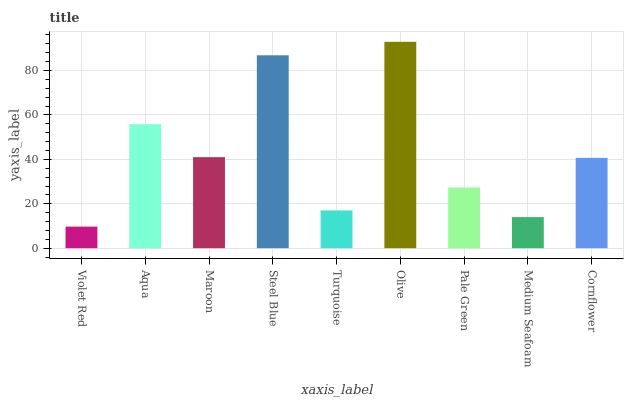Is Violet Red the minimum?
Answer yes or no. Yes. Is Olive the maximum?
Answer yes or no. Yes. Is Aqua the minimum?
Answer yes or no. No. Is Aqua the maximum?
Answer yes or no. No. Is Aqua greater than Violet Red?
Answer yes or no. Yes. Is Violet Red less than Aqua?
Answer yes or no. Yes. Is Violet Red greater than Aqua?
Answer yes or no. No. Is Aqua less than Violet Red?
Answer yes or no. No. Is Cornflower the high median?
Answer yes or no. Yes. Is Cornflower the low median?
Answer yes or no. Yes. Is Pale Green the high median?
Answer yes or no. No. Is Pale Green the low median?
Answer yes or no. No. 